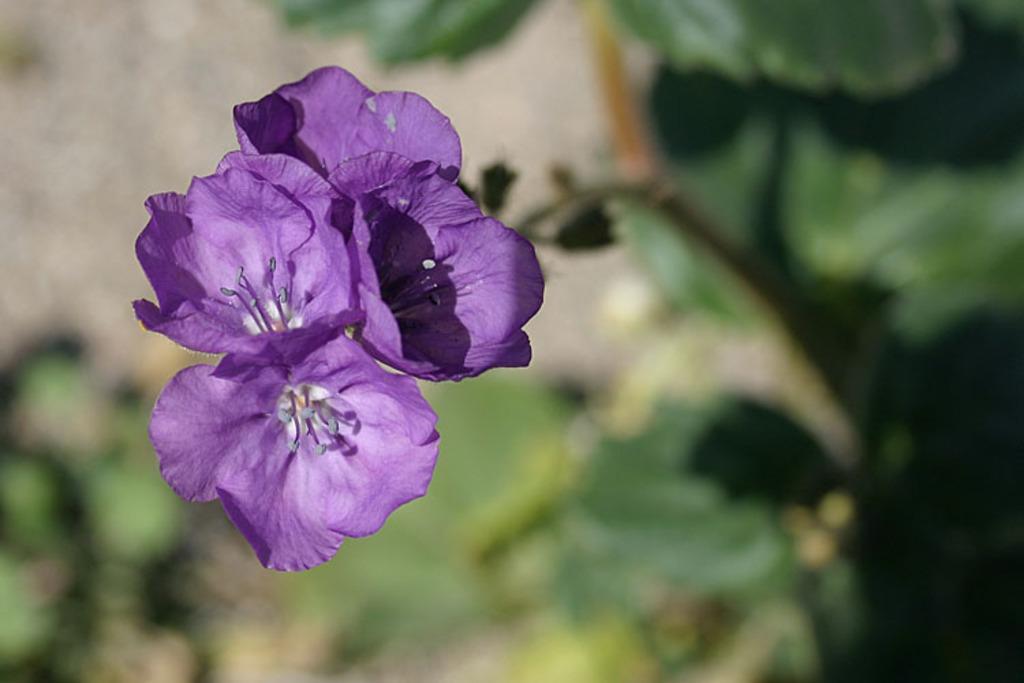Describe this image in one or two sentences. In this image I can see few purple color flowers. Background is in green color and it is blurred. 